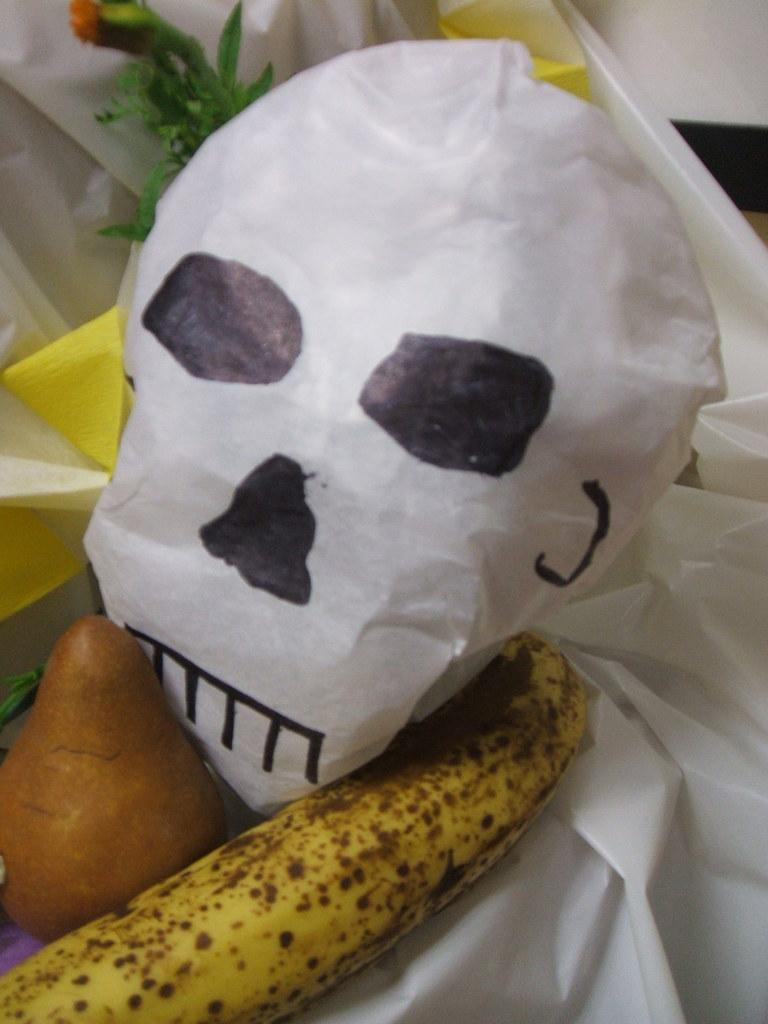What type of fruit is present in the image? There is a banana in the image, which is a fruit. What is the color of the other fruit in the image? There is a brown color fruit in the image. What is wrapped around the brown fruit? There is a white color paper wrapper in the image. What is depicted on the paper wrapper? A danger skeleton is drawn on the paper wrapper. What type of building can be seen in the image? There is no building present in the image. How does the peace symbol contribute to the image? There is no peace symbol present in the image. 